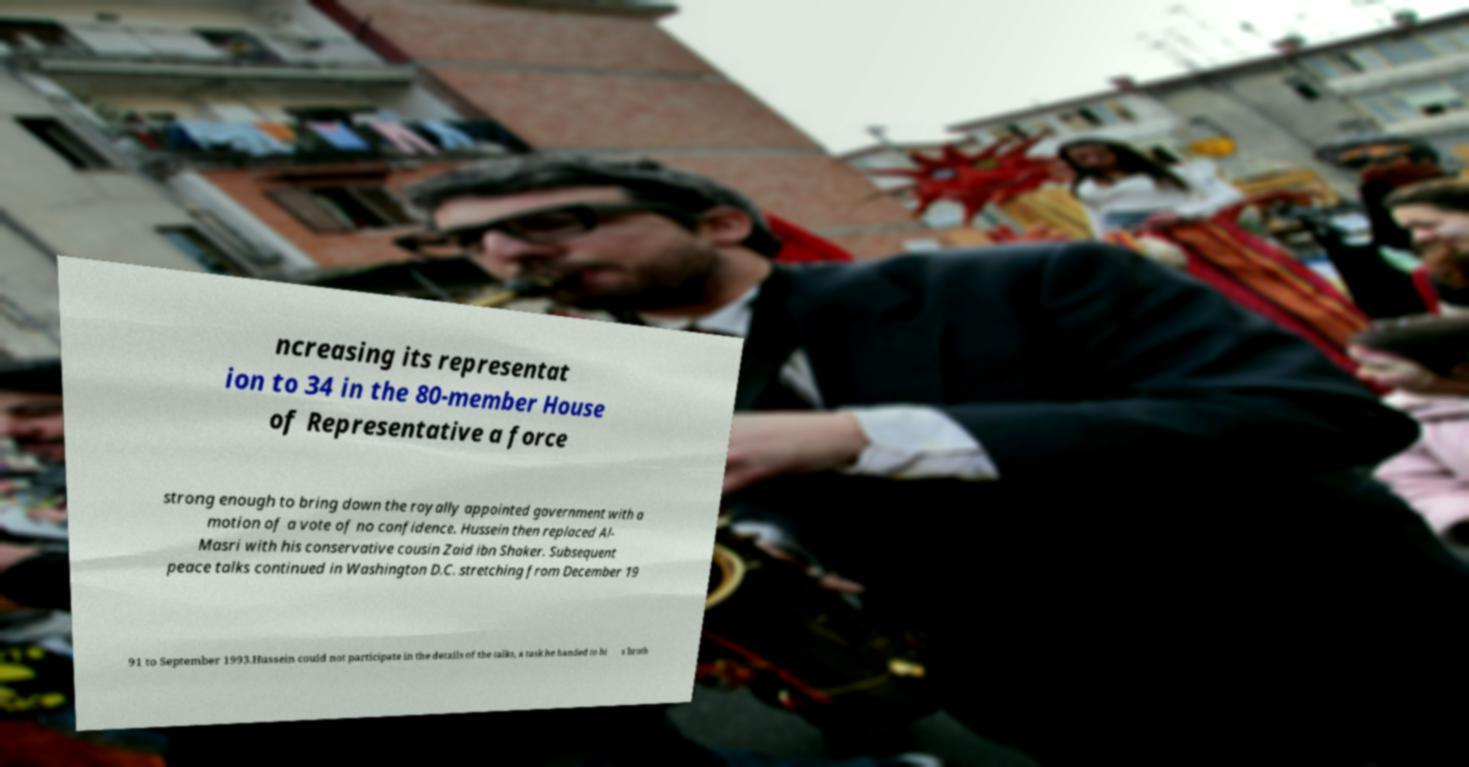What messages or text are displayed in this image? I need them in a readable, typed format. ncreasing its representat ion to 34 in the 80-member House of Representative a force strong enough to bring down the royally appointed government with a motion of a vote of no confidence. Hussein then replaced Al- Masri with his conservative cousin Zaid ibn Shaker. Subsequent peace talks continued in Washington D.C. stretching from December 19 91 to September 1993.Hussein could not participate in the details of the talks, a task he handed to hi s broth 